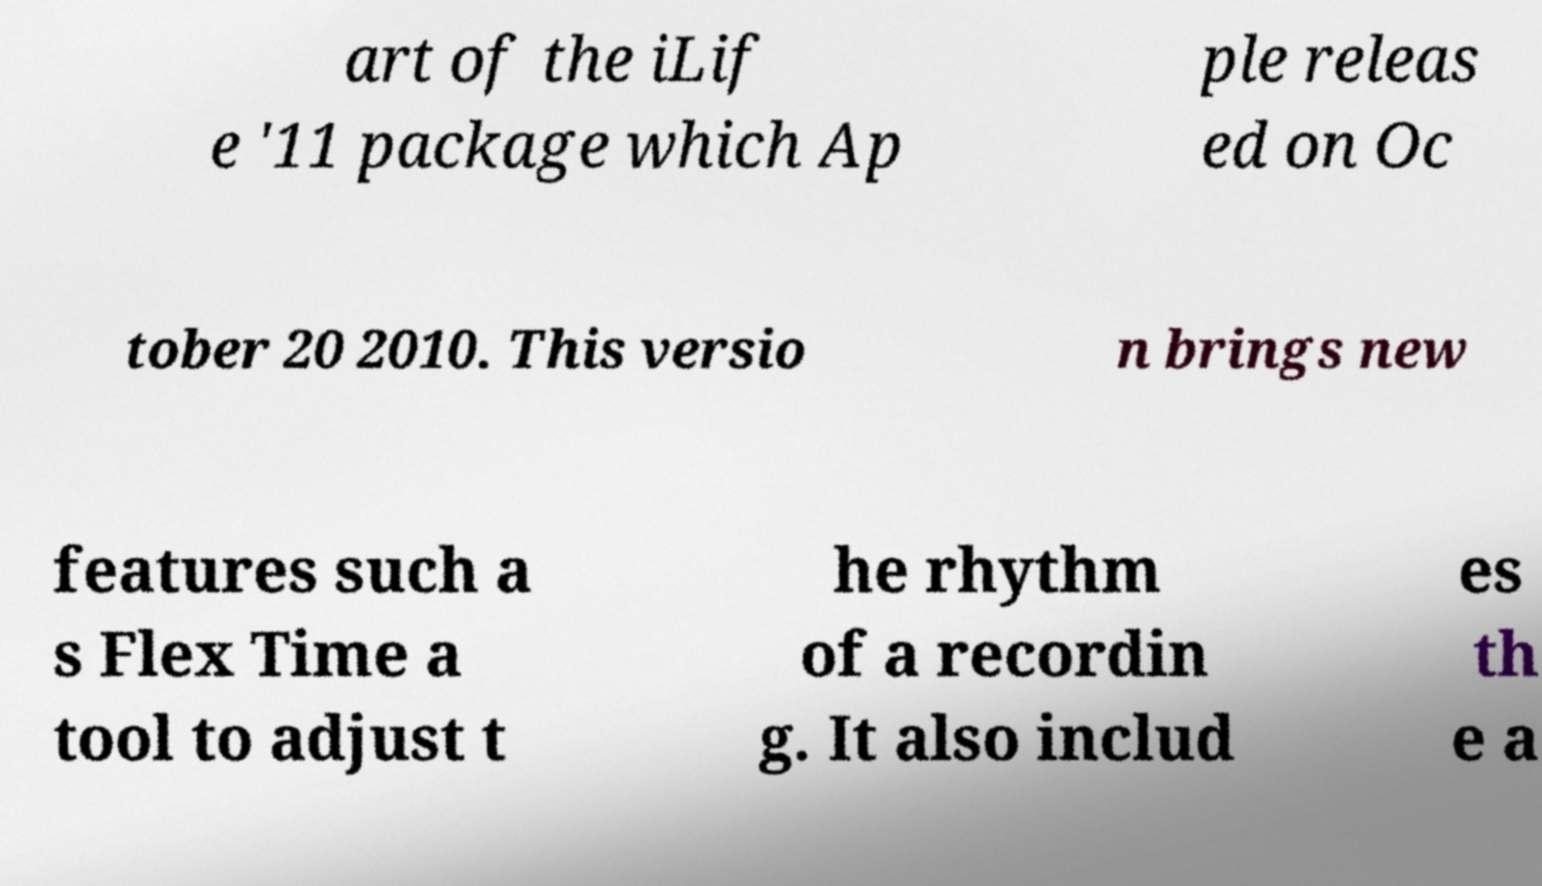Could you assist in decoding the text presented in this image and type it out clearly? art of the iLif e '11 package which Ap ple releas ed on Oc tober 20 2010. This versio n brings new features such a s Flex Time a tool to adjust t he rhythm of a recordin g. It also includ es th e a 